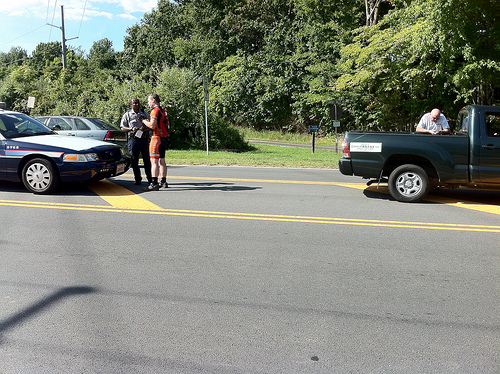<image>
Is there a person in the car? No. The person is not contained within the car. These objects have a different spatial relationship. 